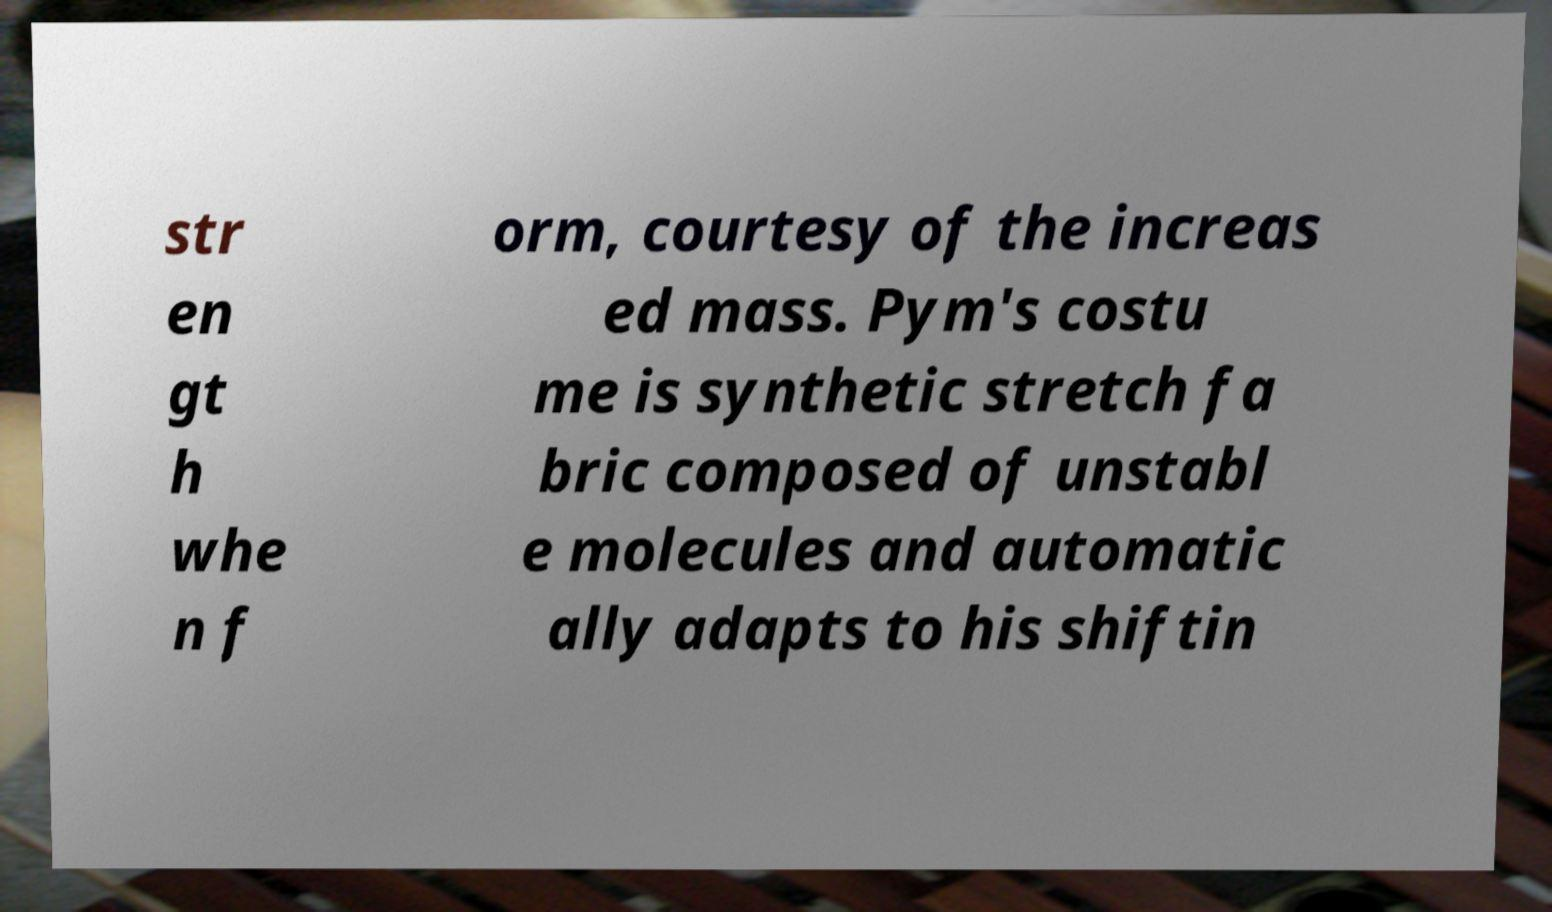Can you read and provide the text displayed in the image?This photo seems to have some interesting text. Can you extract and type it out for me? str en gt h whe n f orm, courtesy of the increas ed mass. Pym's costu me is synthetic stretch fa bric composed of unstabl e molecules and automatic ally adapts to his shiftin 